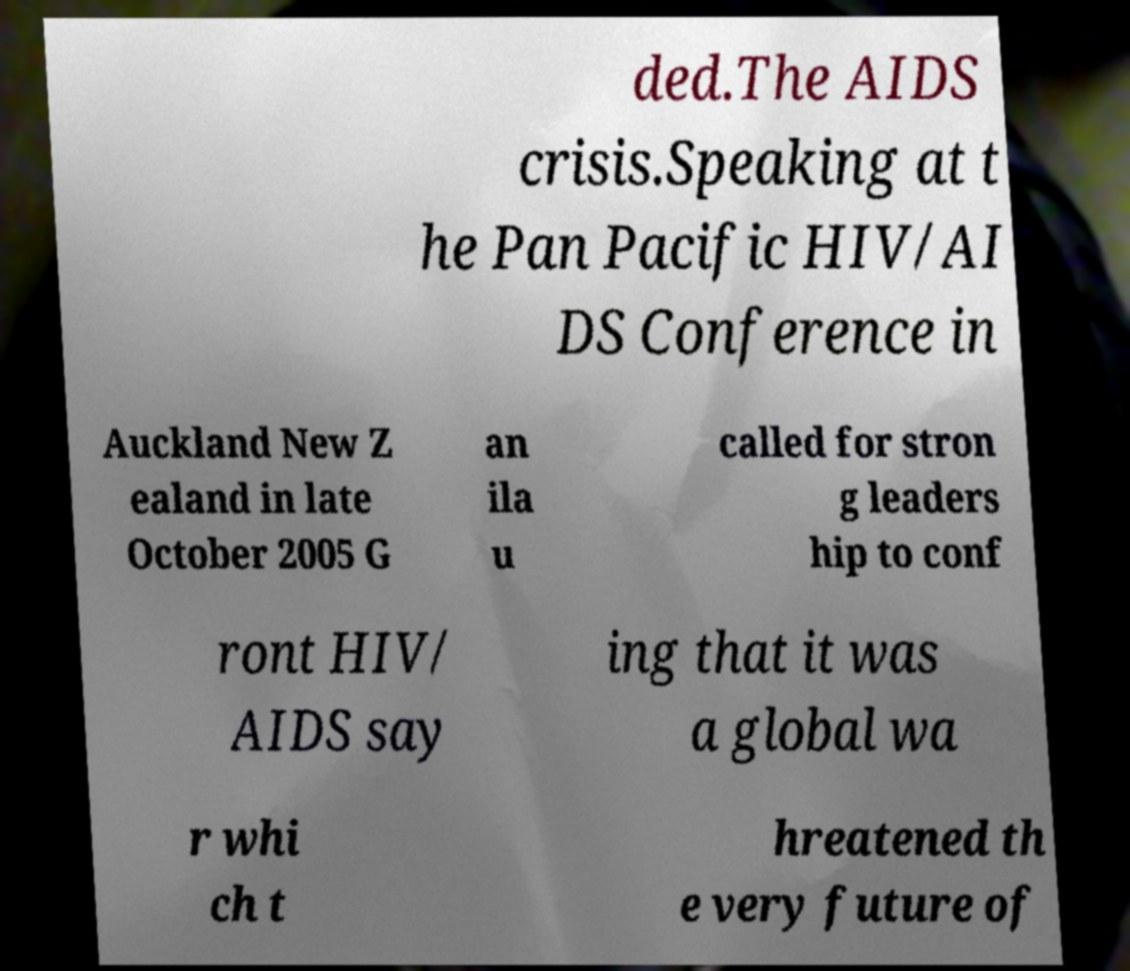For documentation purposes, I need the text within this image transcribed. Could you provide that? ded.The AIDS crisis.Speaking at t he Pan Pacific HIV/AI DS Conference in Auckland New Z ealand in late October 2005 G an ila u called for stron g leaders hip to conf ront HIV/ AIDS say ing that it was a global wa r whi ch t hreatened th e very future of 